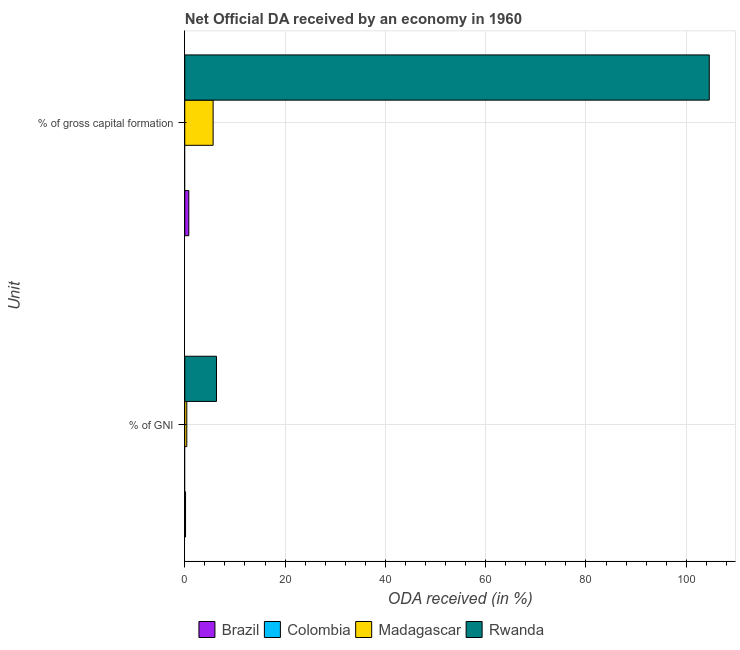How many groups of bars are there?
Provide a succinct answer. 2. What is the label of the 1st group of bars from the top?
Provide a short and direct response. % of gross capital formation. What is the oda received as percentage of gni in Colombia?
Provide a succinct answer. 0. Across all countries, what is the maximum oda received as percentage of gni?
Offer a terse response. 6.33. In which country was the oda received as percentage of gni maximum?
Offer a very short reply. Rwanda. What is the total oda received as percentage of gross capital formation in the graph?
Offer a very short reply. 111.05. What is the difference between the oda received as percentage of gross capital formation in Brazil and that in Madagascar?
Your answer should be compact. -4.85. What is the difference between the oda received as percentage of gross capital formation in Brazil and the oda received as percentage of gni in Madagascar?
Offer a terse response. 0.4. What is the average oda received as percentage of gni per country?
Ensure brevity in your answer.  1.72. What is the difference between the oda received as percentage of gross capital formation and oda received as percentage of gni in Brazil?
Offer a terse response. 0.65. What is the ratio of the oda received as percentage of gni in Rwanda to that in Madagascar?
Keep it short and to the point. 15.54. How many bars are there?
Provide a succinct answer. 6. What is the difference between two consecutive major ticks on the X-axis?
Provide a short and direct response. 20. Are the values on the major ticks of X-axis written in scientific E-notation?
Your answer should be very brief. No. Does the graph contain any zero values?
Keep it short and to the point. Yes. Where does the legend appear in the graph?
Give a very brief answer. Bottom center. How are the legend labels stacked?
Give a very brief answer. Horizontal. What is the title of the graph?
Provide a short and direct response. Net Official DA received by an economy in 1960. What is the label or title of the X-axis?
Make the answer very short. ODA received (in %). What is the label or title of the Y-axis?
Offer a terse response. Unit. What is the ODA received (in %) in Brazil in % of GNI?
Keep it short and to the point. 0.16. What is the ODA received (in %) in Madagascar in % of GNI?
Keep it short and to the point. 0.41. What is the ODA received (in %) of Rwanda in % of GNI?
Keep it short and to the point. 6.33. What is the ODA received (in %) of Brazil in % of gross capital formation?
Make the answer very short. 0.81. What is the ODA received (in %) in Madagascar in % of gross capital formation?
Provide a succinct answer. 5.66. What is the ODA received (in %) in Rwanda in % of gross capital formation?
Your answer should be very brief. 104.58. Across all Unit, what is the maximum ODA received (in %) of Brazil?
Offer a terse response. 0.81. Across all Unit, what is the maximum ODA received (in %) of Madagascar?
Offer a terse response. 5.66. Across all Unit, what is the maximum ODA received (in %) of Rwanda?
Keep it short and to the point. 104.58. Across all Unit, what is the minimum ODA received (in %) of Brazil?
Ensure brevity in your answer.  0.16. Across all Unit, what is the minimum ODA received (in %) of Madagascar?
Give a very brief answer. 0.41. Across all Unit, what is the minimum ODA received (in %) of Rwanda?
Keep it short and to the point. 6.33. What is the total ODA received (in %) of Brazil in the graph?
Provide a succinct answer. 0.97. What is the total ODA received (in %) in Colombia in the graph?
Offer a very short reply. 0. What is the total ODA received (in %) of Madagascar in the graph?
Offer a terse response. 6.06. What is the total ODA received (in %) of Rwanda in the graph?
Offer a very short reply. 110.91. What is the difference between the ODA received (in %) in Brazil in % of GNI and that in % of gross capital formation?
Provide a short and direct response. -0.65. What is the difference between the ODA received (in %) of Madagascar in % of GNI and that in % of gross capital formation?
Give a very brief answer. -5.25. What is the difference between the ODA received (in %) of Rwanda in % of GNI and that in % of gross capital formation?
Your response must be concise. -98.26. What is the difference between the ODA received (in %) in Brazil in % of GNI and the ODA received (in %) in Madagascar in % of gross capital formation?
Offer a very short reply. -5.5. What is the difference between the ODA received (in %) of Brazil in % of GNI and the ODA received (in %) of Rwanda in % of gross capital formation?
Your response must be concise. -104.42. What is the difference between the ODA received (in %) of Madagascar in % of GNI and the ODA received (in %) of Rwanda in % of gross capital formation?
Provide a succinct answer. -104.18. What is the average ODA received (in %) in Brazil per Unit?
Your answer should be very brief. 0.48. What is the average ODA received (in %) in Madagascar per Unit?
Make the answer very short. 3.03. What is the average ODA received (in %) of Rwanda per Unit?
Keep it short and to the point. 55.46. What is the difference between the ODA received (in %) in Brazil and ODA received (in %) in Madagascar in % of GNI?
Your answer should be very brief. -0.25. What is the difference between the ODA received (in %) in Brazil and ODA received (in %) in Rwanda in % of GNI?
Your answer should be compact. -6.17. What is the difference between the ODA received (in %) in Madagascar and ODA received (in %) in Rwanda in % of GNI?
Ensure brevity in your answer.  -5.92. What is the difference between the ODA received (in %) of Brazil and ODA received (in %) of Madagascar in % of gross capital formation?
Provide a succinct answer. -4.85. What is the difference between the ODA received (in %) in Brazil and ODA received (in %) in Rwanda in % of gross capital formation?
Offer a very short reply. -103.78. What is the difference between the ODA received (in %) in Madagascar and ODA received (in %) in Rwanda in % of gross capital formation?
Keep it short and to the point. -98.93. What is the ratio of the ODA received (in %) in Brazil in % of GNI to that in % of gross capital formation?
Give a very brief answer. 0.2. What is the ratio of the ODA received (in %) of Madagascar in % of GNI to that in % of gross capital formation?
Your response must be concise. 0.07. What is the ratio of the ODA received (in %) in Rwanda in % of GNI to that in % of gross capital formation?
Offer a very short reply. 0.06. What is the difference between the highest and the second highest ODA received (in %) of Brazil?
Offer a very short reply. 0.65. What is the difference between the highest and the second highest ODA received (in %) in Madagascar?
Offer a very short reply. 5.25. What is the difference between the highest and the second highest ODA received (in %) of Rwanda?
Your answer should be very brief. 98.26. What is the difference between the highest and the lowest ODA received (in %) of Brazil?
Provide a succinct answer. 0.65. What is the difference between the highest and the lowest ODA received (in %) in Madagascar?
Keep it short and to the point. 5.25. What is the difference between the highest and the lowest ODA received (in %) of Rwanda?
Give a very brief answer. 98.26. 